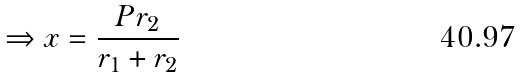<formula> <loc_0><loc_0><loc_500><loc_500>\Rightarrow x = \frac { P r _ { 2 } } { r _ { 1 } + r _ { 2 } }</formula> 